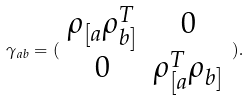Convert formula to latex. <formula><loc_0><loc_0><loc_500><loc_500>\gamma _ { a b } = ( \begin{array} { c c } \rho _ { [ a } \rho _ { b ] } ^ { T } & 0 \\ 0 & \rho _ { [ a } ^ { T } \rho _ { b ] } \end{array} ) .</formula> 